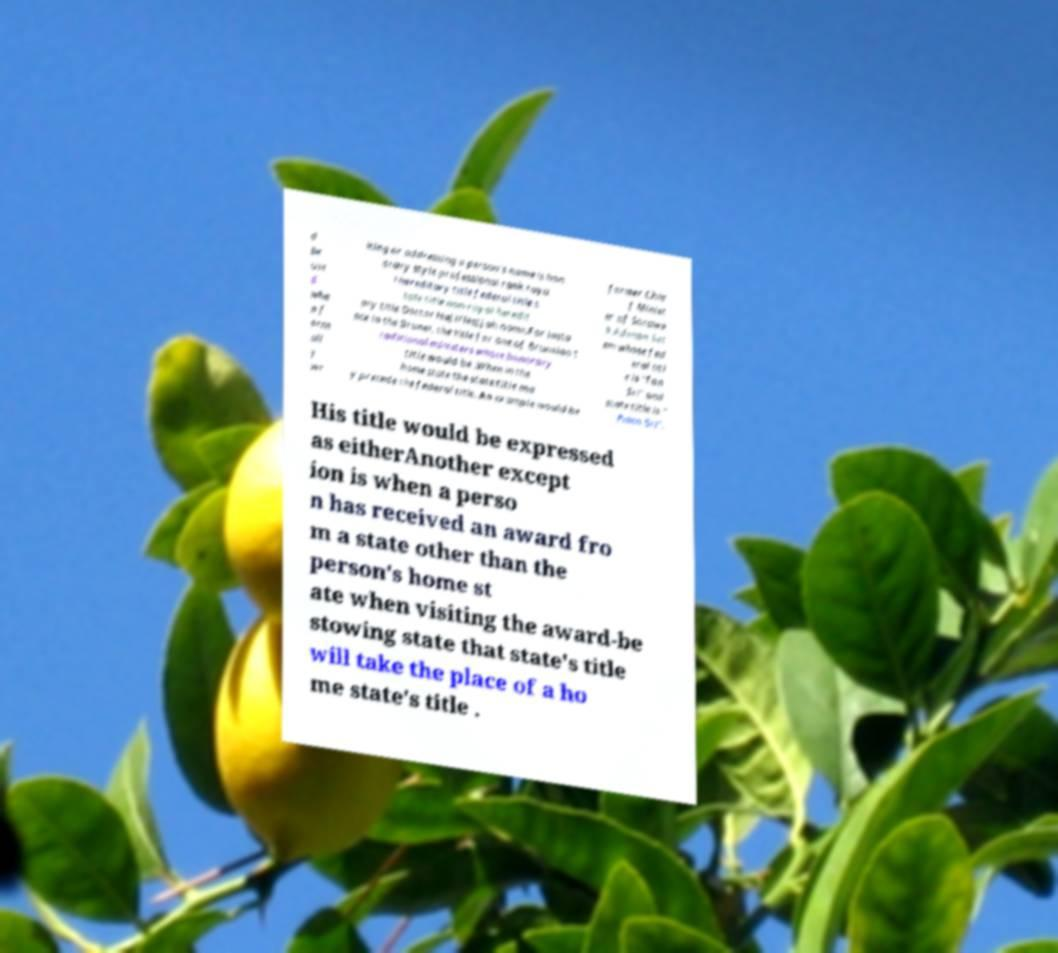Please read and relay the text visible in this image. What does it say? d be use d whe n f orm all y wr iting or addressing a person's name is hon orary style professional rank roya l hereditary title federal title s tate title non-royal heredit ary title Doctor Haji/Hajjah name.For insta nce in the Brunei, the title for one of Bruneian t raditional ministers whose honorary title would be .When in the home state the state title ma y precede the federal title. An example would be former Chie f Minist er of Sarawa k Adenan Sat em whose fed eral titl e is "Tan Sri" and state title is " Pehin Sri". His title would be expressed as eitherAnother except ion is when a perso n has received an award fro m a state other than the person's home st ate when visiting the award-be stowing state that state's title will take the place of a ho me state's title . 